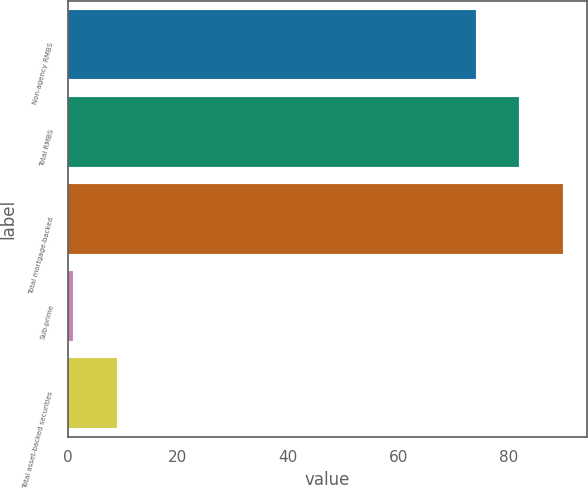Convert chart. <chart><loc_0><loc_0><loc_500><loc_500><bar_chart><fcel>Non-agency RMBS<fcel>Total RMBS<fcel>Total mortgage-backed<fcel>Sub-prime<fcel>Total asset-backed securities<nl><fcel>74<fcel>81.9<fcel>89.8<fcel>1<fcel>8.9<nl></chart> 